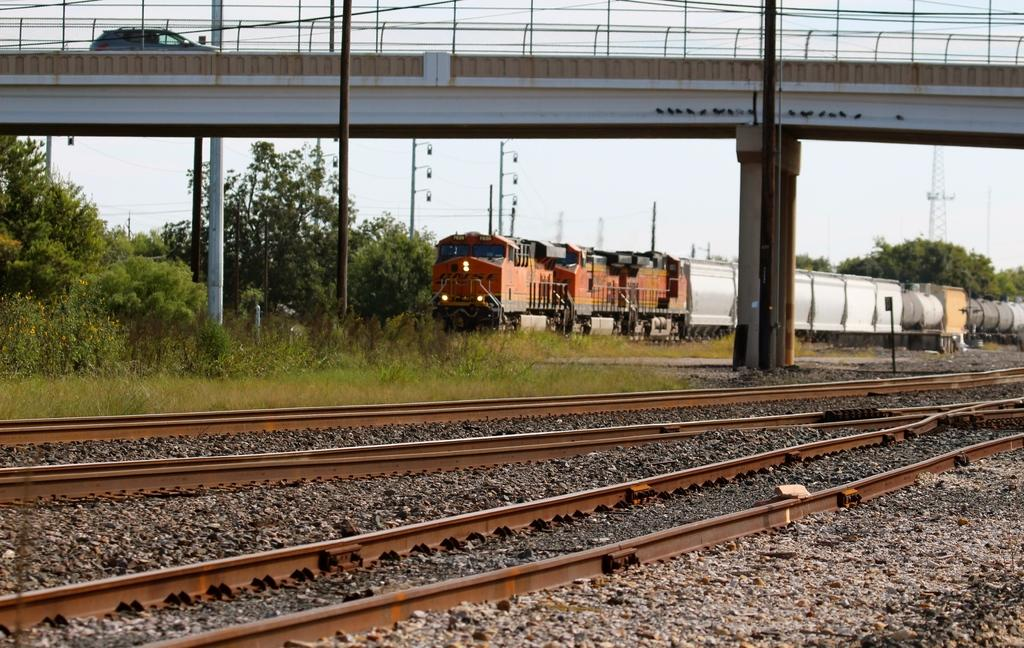What type of transportation infrastructure is present in the image? There are train tracks in the image. What natural elements can be seen in the image? There are rocks, grass, trees, and sky visible in the image. What man-made structures are present in the image? There is a bridge, poles, a tower, and a vehicle in the image. What type of vehicle is in the image? The vehicle is a train in the image. Where is the train located in the image? The train is on the bridge in the image. How many objects can be identified in the image? There are at least 12 objects in the image. How does the sock help the train move faster in the image? There is no sock present in the image, and therefore it cannot affect the train's speed. What type of arch can be seen supporting the bridge in the image? There is no arch visible in the image; the bridge appears to be supported by poles. 